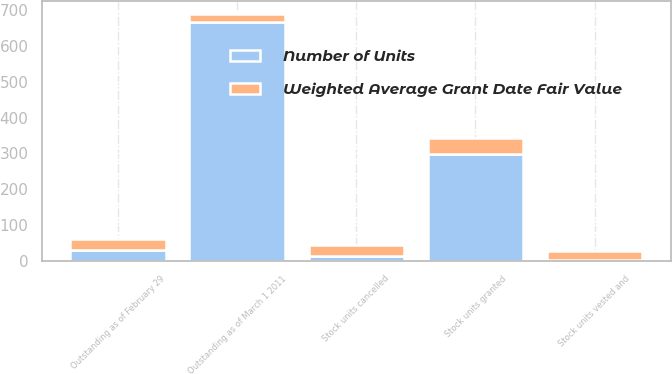Convert chart. <chart><loc_0><loc_0><loc_500><loc_500><stacked_bar_chart><ecel><fcel>Outstanding as of March 1 2011<fcel>Stock units granted<fcel>Stock units vested and<fcel>Stock units cancelled<fcel>Outstanding as of February 29<nl><fcel>Number of Units<fcel>666<fcel>299<fcel>2<fcel>13<fcel>31.02<nl><fcel>Weighted Average Grant Date Fair Value<fcel>24.66<fcel>45.48<fcel>24.19<fcel>31.02<fcel>31.12<nl></chart> 